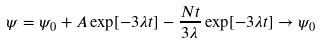Convert formula to latex. <formula><loc_0><loc_0><loc_500><loc_500>\psi = \psi _ { 0 } + A \exp [ - 3 \lambda t ] - \frac { N t } { 3 \lambda } \exp [ - 3 \lambda t ] \rightarrow \psi _ { 0 }</formula> 